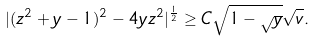Convert formula to latex. <formula><loc_0><loc_0><loc_500><loc_500>| ( z ^ { 2 } + y - 1 ) ^ { 2 } - 4 y z ^ { 2 } | ^ { \frac { 1 } { 2 } } \geq C \sqrt { 1 - \sqrt { y } } \sqrt { v } .</formula> 